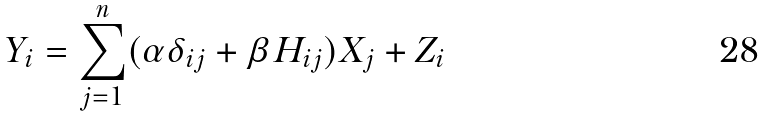<formula> <loc_0><loc_0><loc_500><loc_500>Y _ { i } = \sum _ { j = 1 } ^ { n } ( \alpha \delta _ { i j } + \beta H _ { i j } ) X _ { j } + Z _ { i }</formula> 